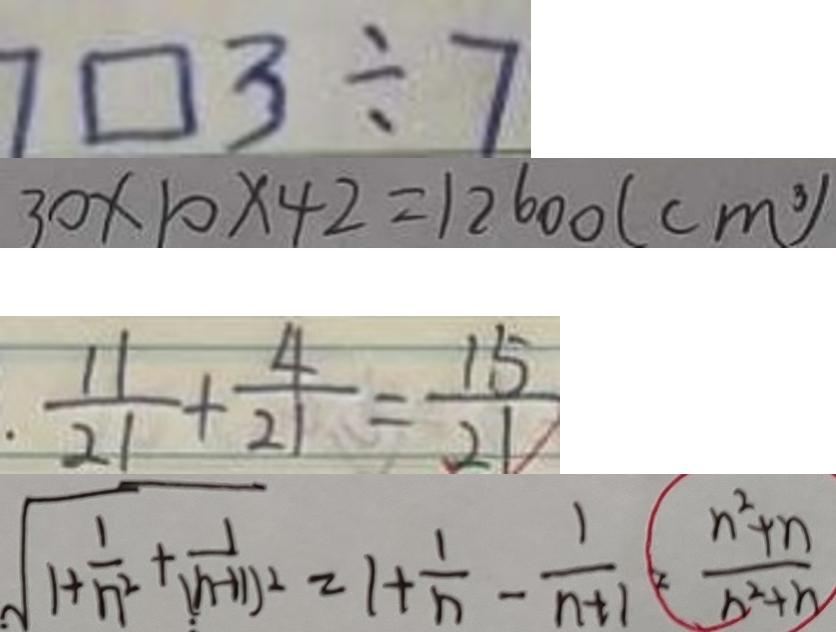Convert formula to latex. <formula><loc_0><loc_0><loc_500><loc_500>7 \square 3 \div 7 
 3 0 \times 1 0 \times 4 2 = 1 2 6 0 0 ( c m ^ { 3 } ) 
 \frac { 1 1 } { 2 1 } + \frac { 4 } { 2 1 } = \frac { 1 5 } { 2 1 } 
 \sqrt { 1 + \frac { 1 } { n ^ { 2 } } + \frac { 1 } { ( n + 1 ) ^ { 2 } } } = 1 + \frac { 1 } { n } - \frac { 1 } { n + 1 } = ( \frac { n ^ { 2 } + n } { n ^ { 2 } + h ) }</formula> 